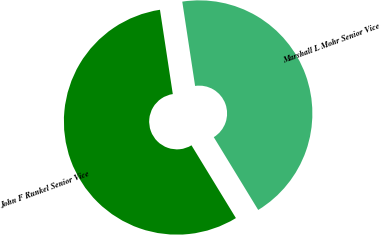Convert chart to OTSL. <chart><loc_0><loc_0><loc_500><loc_500><pie_chart><fcel>Marshall L Mohr Senior Vice<fcel>John F Runkel Senior Vice<nl><fcel>43.68%<fcel>56.32%<nl></chart> 